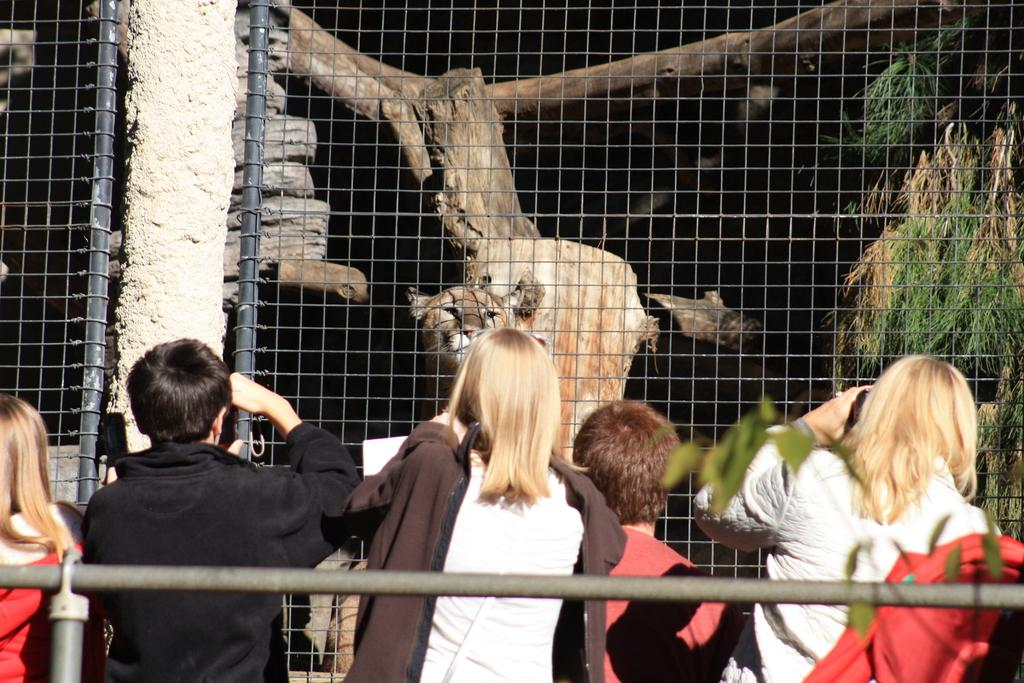Who is present in the image? There are people in the image. What are the people doing near the railing? The people are standing near a railing and capturing pictures. What is the location of the lion in the image? The lion is in a cage in the image. What type of vegetation can be seen in the image? There are plants visible in the image. How many cars can be seen in the image? There are no cars present in the image. Is there a servant attending to the people in the image? There is no mention of a servant in the image. 